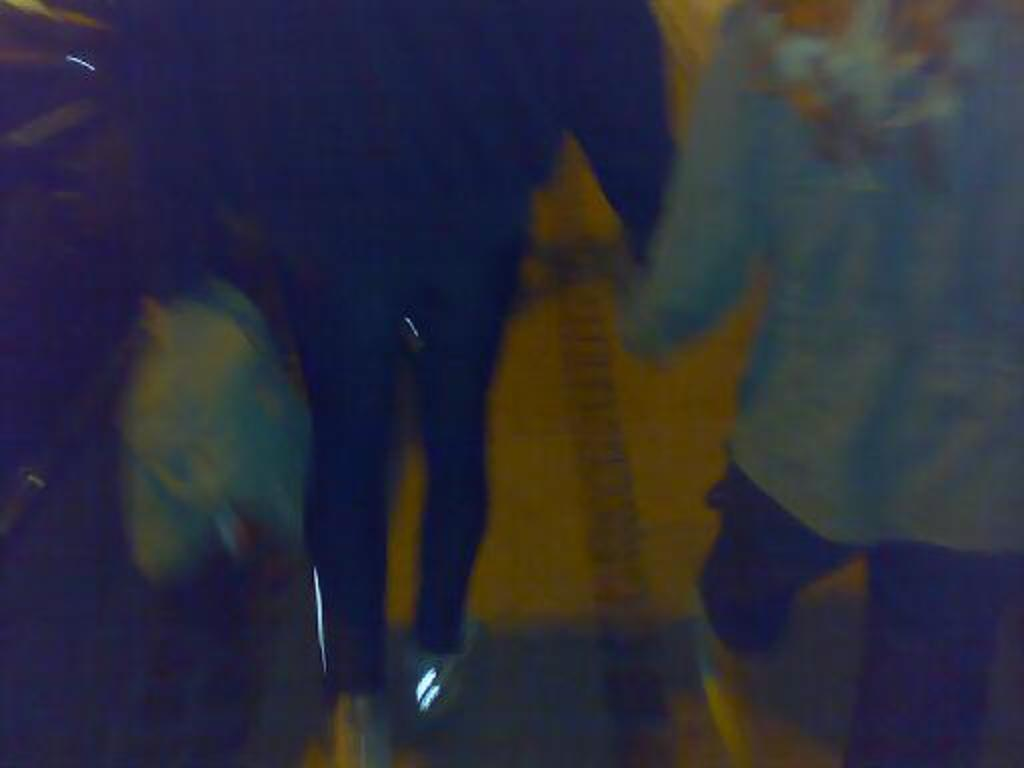How many people are in the image? There are two people in the image. What are the two people doing? The two people are holding hands and walking. Where are the two people walking? They are walking on a platform. What type of plants can be seen growing on the platform in the image? There are no plants visible in the image; it only shows two people holding hands and walking on a platform. 